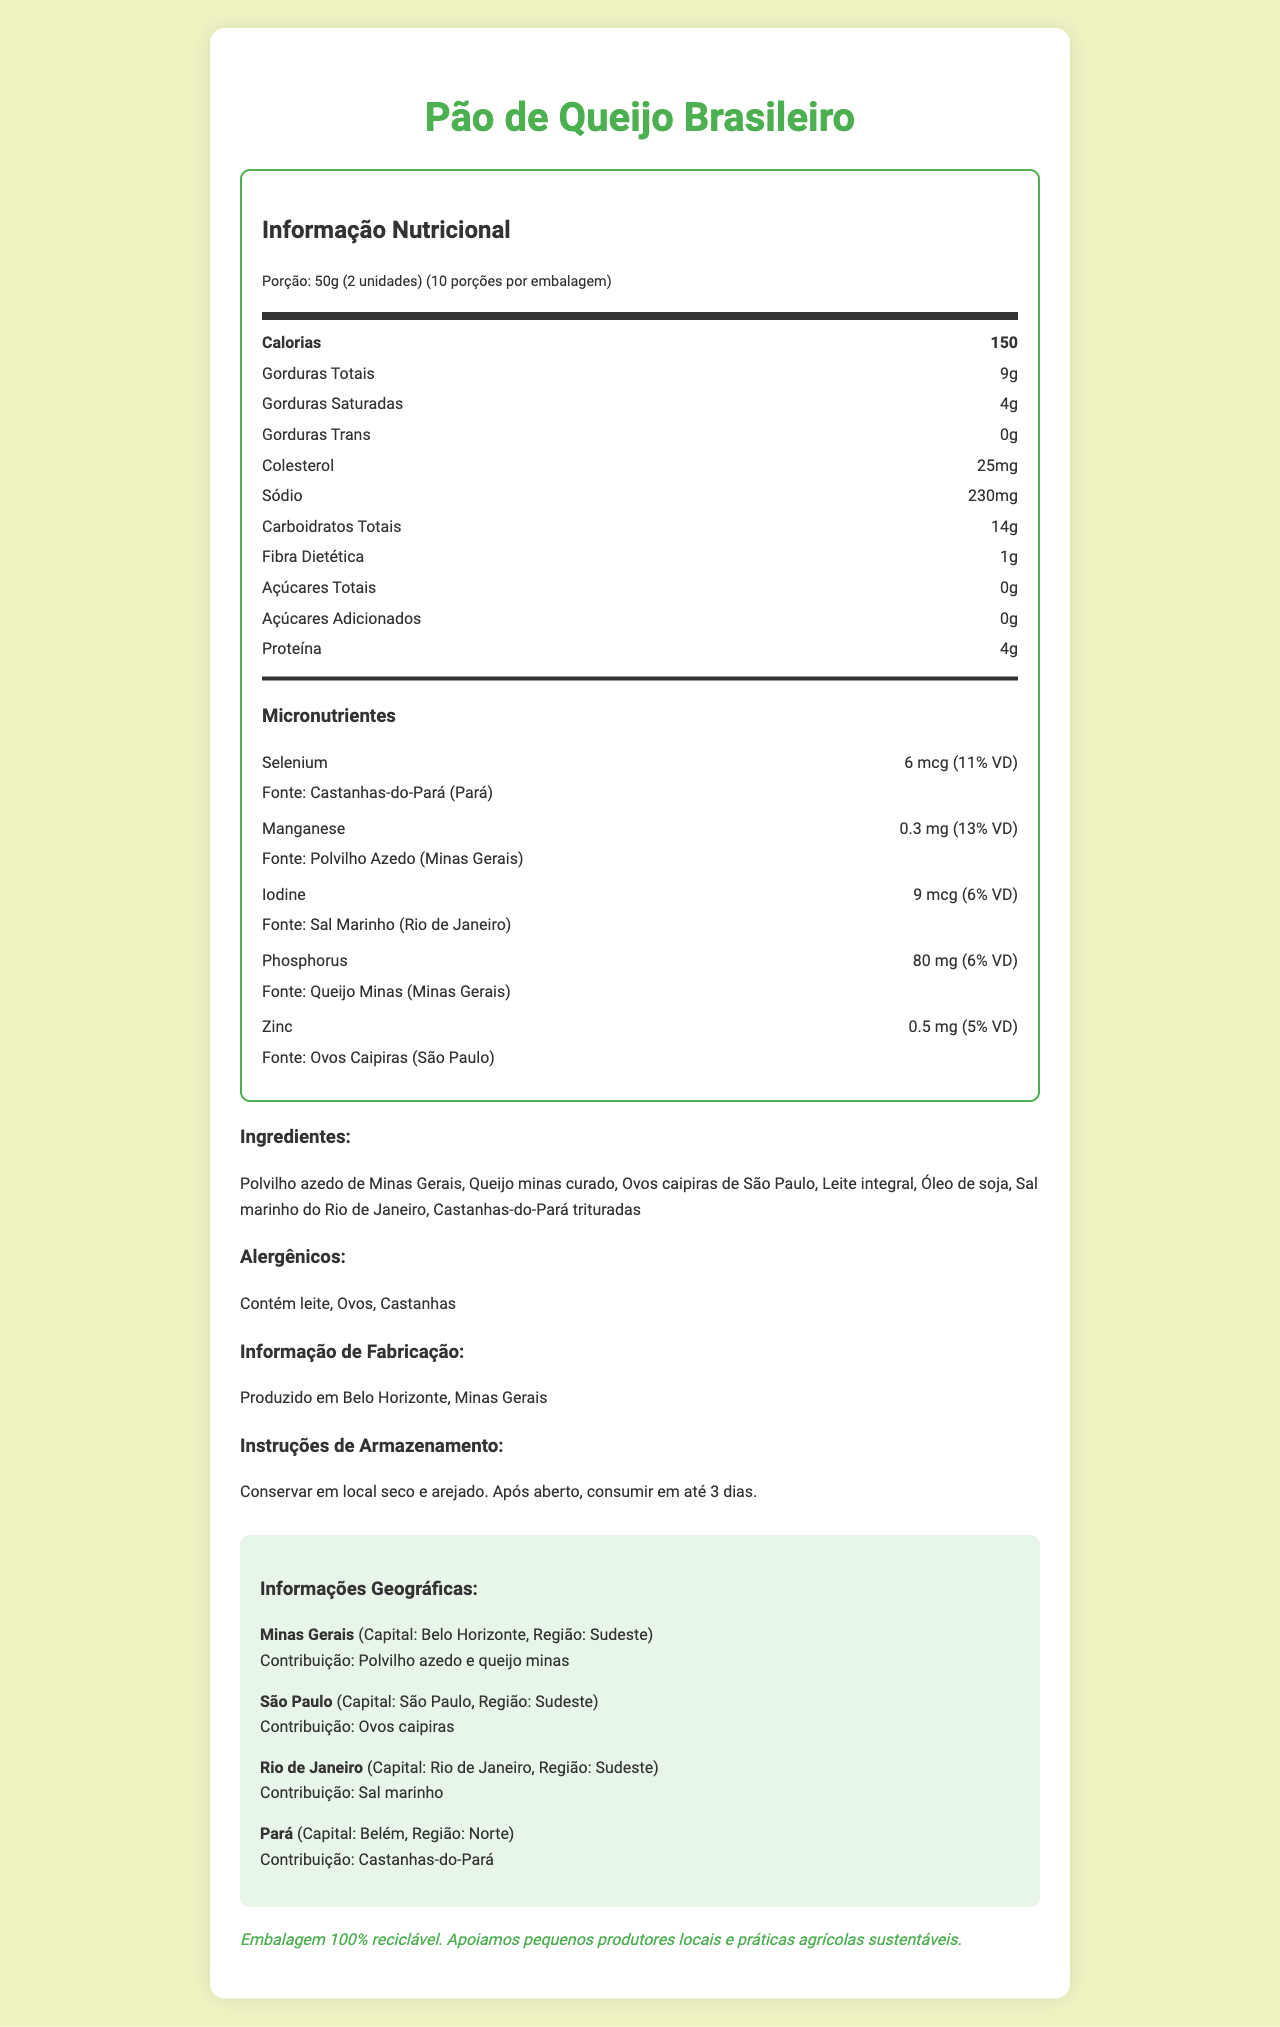what is the serving size of the product? The serving size of the product is displayed as "50g (2 unidades)" under the "Informação Nutricional" section.
Answer: 50g (2 unidades) how many servings are in the container? The document states "10 porções por embalagem" in the serving information section.
Answer: 10 what is the source of Selenium? The source of Selenium is mentioned as "Castanhas-do-Pará (Pará)" in the micronutrients section.
Answer: Castanhas-do-Pará (Pará) what is the protein content per serving? The protein content per serving is listed as "4g" in the main nutrients section.
Answer: 4g what are the allergens mentioned? The allergens are listed under the "Alergênicos" section and they include "Contém leite, Ovos, Castanhas".
Answer: Contém leite, Ovos, Castanhas what state is associated with the contribution of Polvilho Azedo? In the geographical information, Minas Gerais is listed as the state contributing Polvilho Azedo.
Answer: Minas Gerais where is the product manufactured? The manufacturing information states that the product is produced in Belo Horizonte, Minas Gerais.
Answer: Belo Horizonte, Minas Gerais which nutrient contributes the most to the daily value percentage? A. Selenium B. Manganese C. Iodine D. Phosphorus Manganese contributes 13% of the daily value, which is higher than Selenium (11%), Iodine (6%), and Phosphorus (6%).
Answer: B which region is São Paulo a part of? A. Norte B. Nordeste C. Sudeste D. Sul São Paulo is part of the Sudeste region, as mentioned in the geographical information section.
Answer: C does the product contain any added sugars? The document states "Açúcares Adicionados: 0g" indicating there are no added sugars.
Answer: No summarize the main idea of the document. The document is a comprehensive Nutrition Facts Label that includes various nutritional details, ingredient sources, manufacturing and storage instructions, alongside the geographical origin of ingredients and sustainability notes.
Answer: The document provides a detailed Nutrition Facts Label for "Pão de Queijo Brasileiro", highlighting its nutritional content, including calories, macronutrients, and micronutrients. It lists ingredients, allergens, manufacturing information, storage instructions, and the geographical origin of key ingredients, emphasizing support for local producers and sustainable practices. which state contributes more than one ingredient? Minas Gerais contributes both "Polvilho Azedo" and "Queijo Minas" as stated in the geographical information section.
Answer: Minas Gerais how much sodium is in one serving of the product? The sodium content per serving is listed as "230mg" in the main nutrients section.
Answer: 230mg what is the primary source of Iodine in the product? The source of Iodine is listed as "Sal Marinho (Rio de Janeiro)" in the micronutrients section.
Answer: Sal Marinho (Rio de Janeiro) how much daily value of Calcium does the product provide per serving? The document states that per serving, the product provides 8% of the daily value for Calcium.
Answer: 8% how many grams of dietary fiber are in each serving? The dietary fiber content per serving is shown as "1g".
Answer: 1g is there any information on the carbon footprint of the product? The document does not provide details on the carbon footprint of the product, only mentioning sustainable practices and recyclable packaging.
Answer: Not enough information 